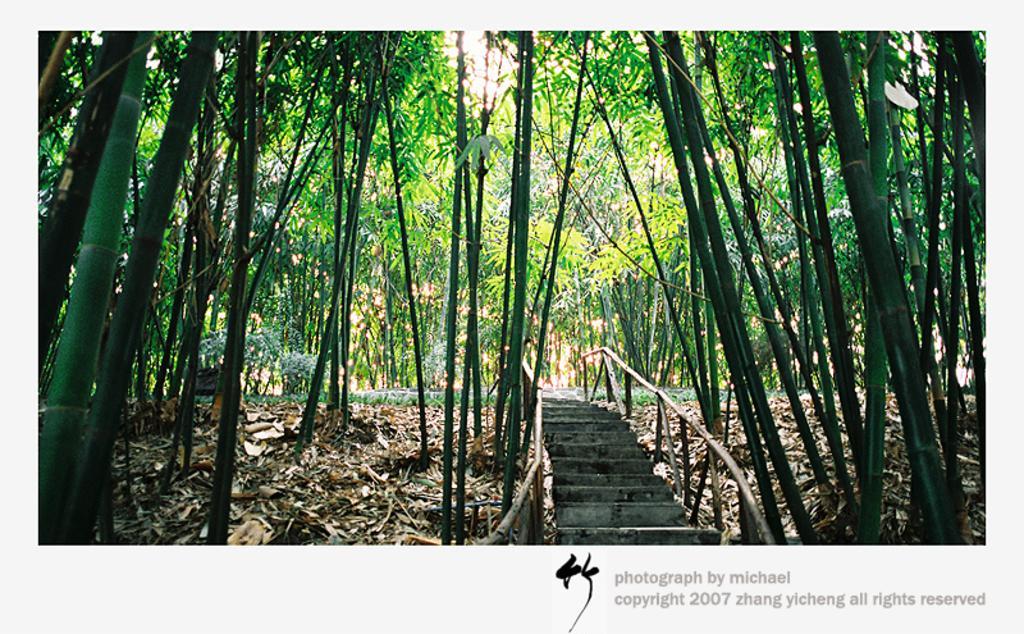Please provide a concise description of this image. In this image we can see trees. At the bottom of the image, we can see stairs, railing and dry leaves on the land. At the top of the image, we can see the sky. We can see a watermark in the right bottom of the image. 